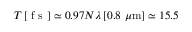Convert formula to latex. <formula><loc_0><loc_0><loc_500><loc_500>T \, [ f s ] \simeq 0 . 9 7 N \lambda \, [ 0 . 8 \mu m ] \simeq 1 5 . 5</formula> 